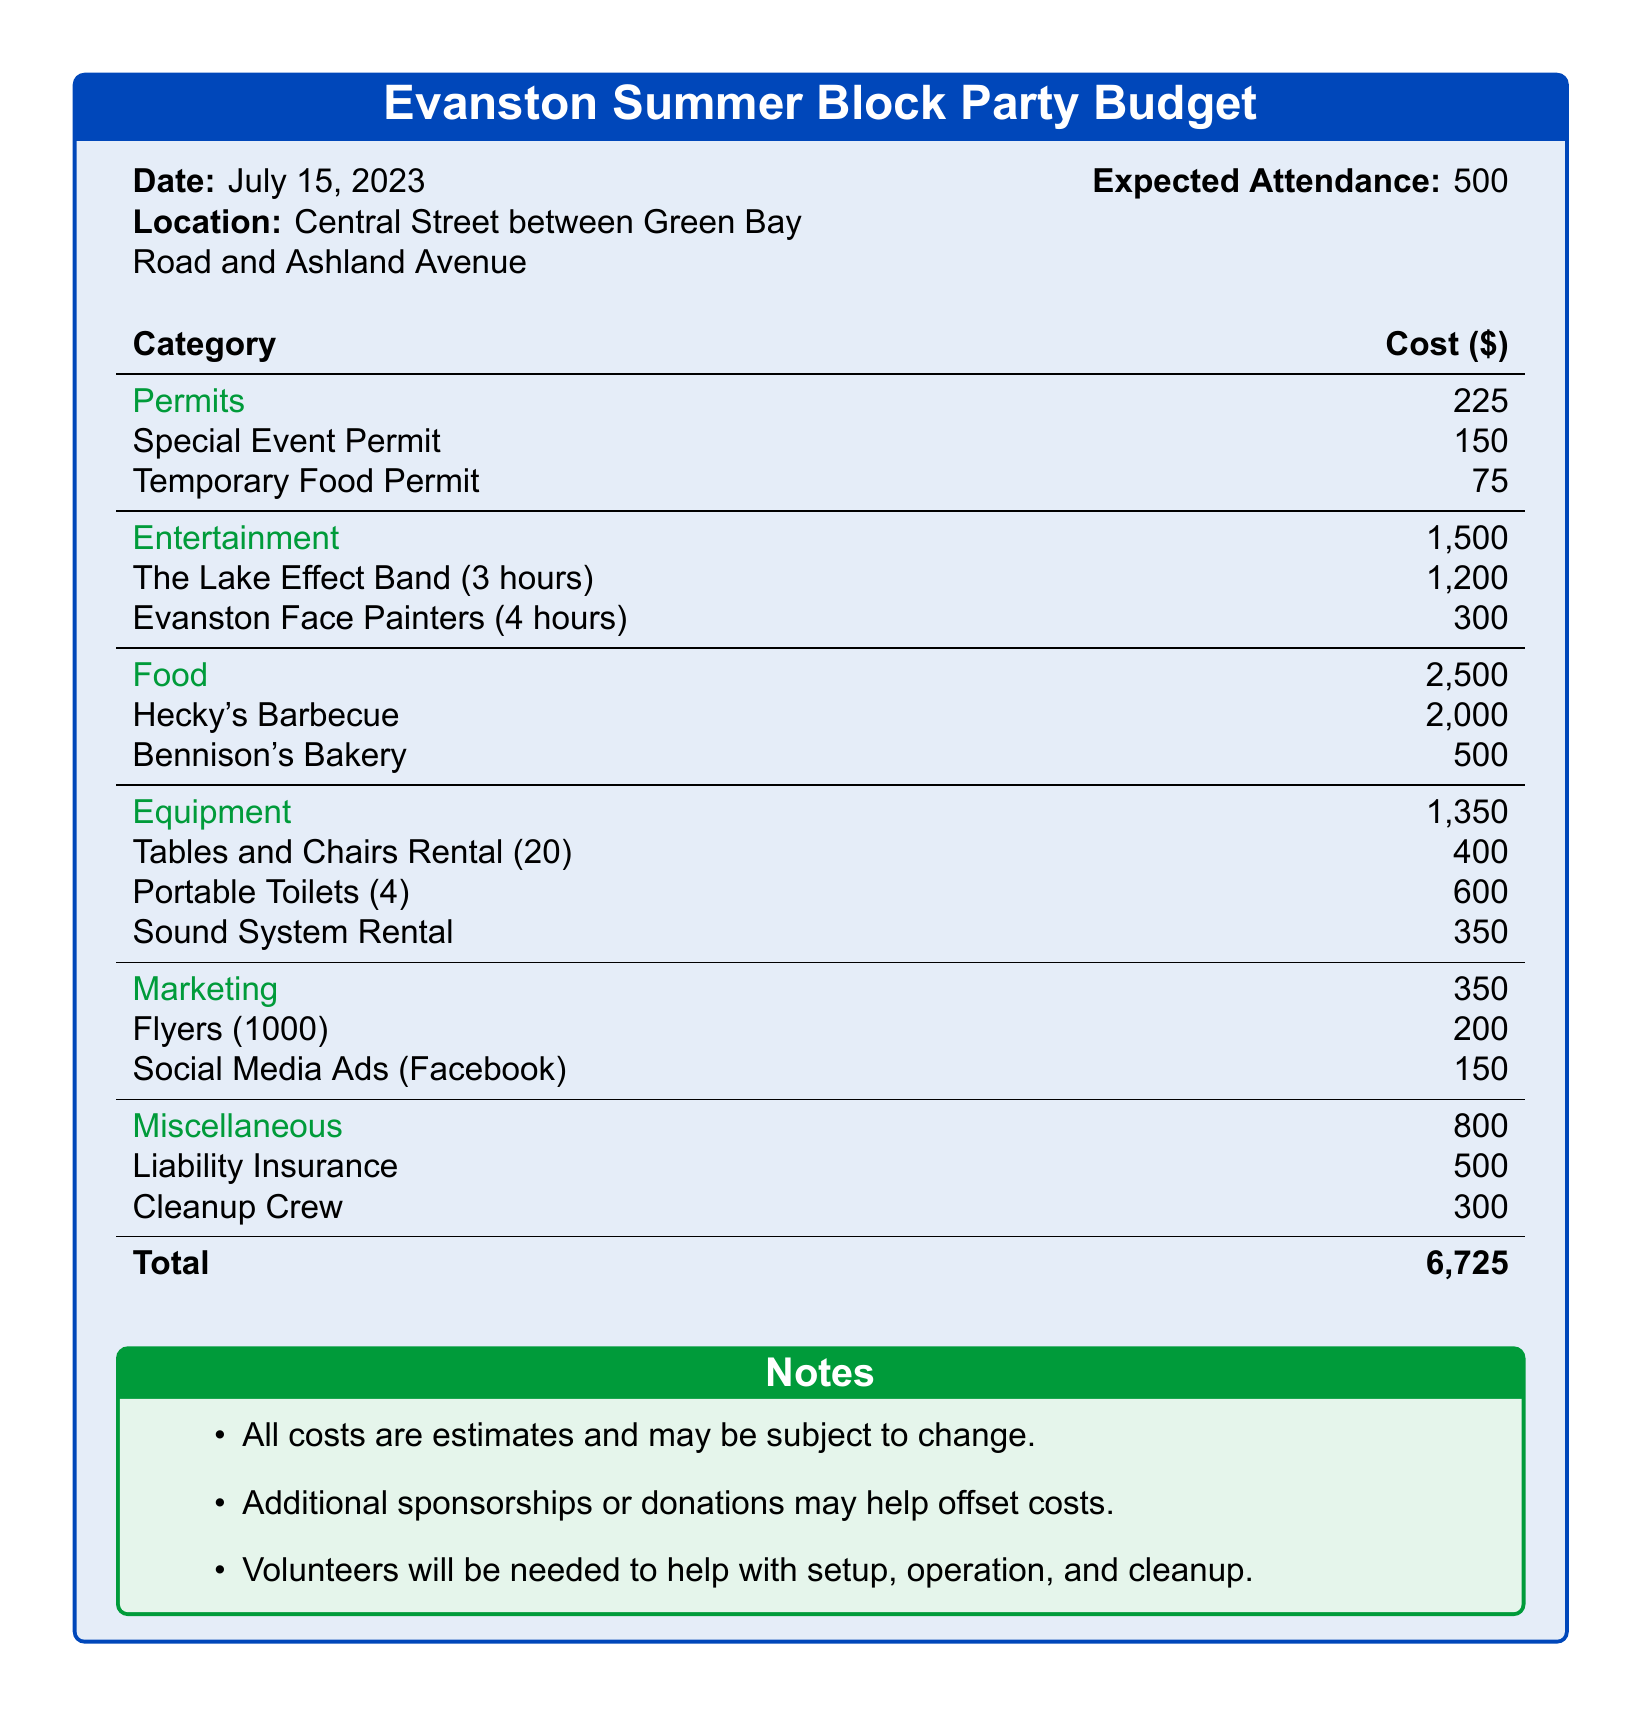what is the date of the event? The date of the event is specified in the document as July 15, 2023.
Answer: July 15, 2023 how much is allocated for entertainment? The budget allocates a specific amount for entertainment, which is listed as 1,500 dollars.
Answer: 1,500 what is the total cost for food? The document states that the total cost for food is 2,500 dollars, including specific vendors.
Answer: 2,500 how many people are expected to attend the block party? The expected attendance is provided in the budget as 500 individuals.
Answer: 500 what is the cost of the Special Event Permit? The document specifies that the cost for the Special Event Permit is 150 dollars.
Answer: 150 how much does the Lake Effect Band charge for their performance? The document indicates that the Lake Effect Band charges 1,200 dollars for a three-hour performance.
Answer: 1,200 what is the total budget for the block party? The total budget is calculated as the sum of all listed costs, which amounts to 6,725 dollars.
Answer: 6,725 what miscellaneous expense is included in the budget? The document lists liability insurance and cleanup crew as miscellaneous expenses totaling 800 dollars.
Answer: liability insurance and cleanup crew how many tables and chairs are being rented? The budget mentions that 20 tables and chairs are being rented for the event.
Answer: 20 